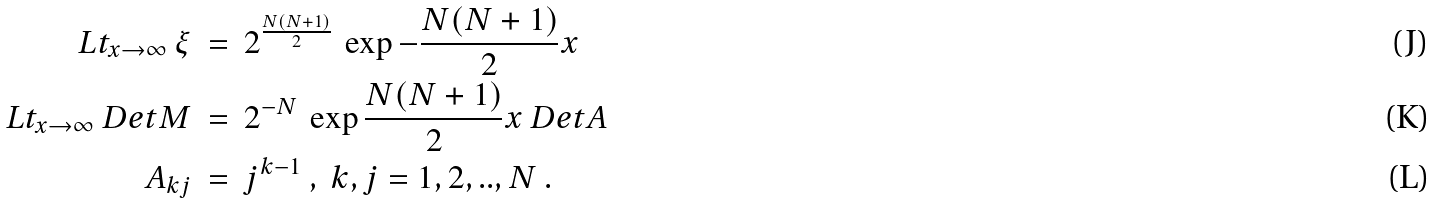Convert formula to latex. <formula><loc_0><loc_0><loc_500><loc_500>L t _ { x \to \infty } \ \xi \ & = \ 2 ^ { \frac { N ( N + 1 ) } { 2 } } \ \exp - \frac { N ( N + 1 ) } { 2 } x \ \\ L t _ { x \to \infty } \ D e t M \ & = \ 2 ^ { - N } \ \exp \frac { N ( N + 1 ) } { 2 } x \ D e t A \\ A _ { k j } \ & = \ j ^ { k - 1 } \ , \ k , j = 1 , 2 , . . , N \ .</formula> 